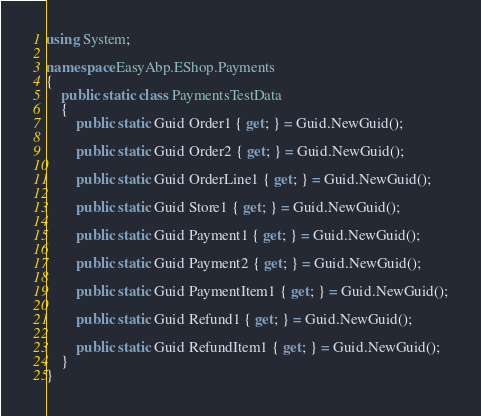Convert code to text. <code><loc_0><loc_0><loc_500><loc_500><_C#_>using System;

namespace EasyAbp.EShop.Payments
{
    public static class PaymentsTestData
    {
        public static Guid Order1 { get; } = Guid.NewGuid();

        public static Guid Order2 { get; } = Guid.NewGuid();
        
        public static Guid OrderLine1 { get; } = Guid.NewGuid();

        public static Guid Store1 { get; } = Guid.NewGuid();

        public static Guid Payment1 { get; } = Guid.NewGuid();
        
        public static Guid Payment2 { get; } = Guid.NewGuid();
        
        public static Guid PaymentItem1 { get; } = Guid.NewGuid();
        
        public static Guid Refund1 { get; } = Guid.NewGuid();
        
        public static Guid RefundItem1 { get; } = Guid.NewGuid();
    }
}</code> 